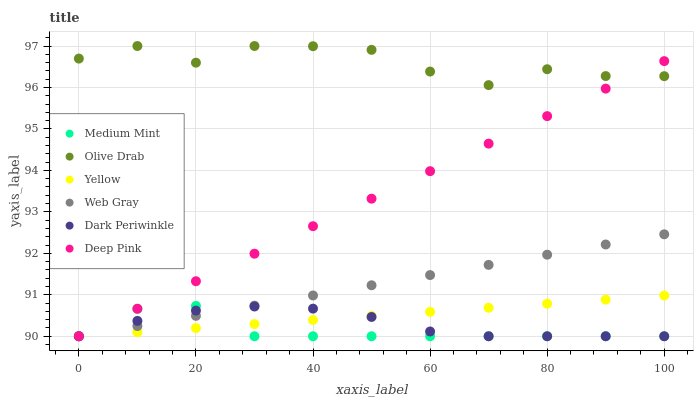Does Medium Mint have the minimum area under the curve?
Answer yes or no. Yes. Does Olive Drab have the maximum area under the curve?
Answer yes or no. Yes. Does Deep Pink have the minimum area under the curve?
Answer yes or no. No. Does Deep Pink have the maximum area under the curve?
Answer yes or no. No. Is Web Gray the smoothest?
Answer yes or no. Yes. Is Olive Drab the roughest?
Answer yes or no. Yes. Is Deep Pink the smoothest?
Answer yes or no. No. Is Deep Pink the roughest?
Answer yes or no. No. Does Medium Mint have the lowest value?
Answer yes or no. Yes. Does Olive Drab have the lowest value?
Answer yes or no. No. Does Olive Drab have the highest value?
Answer yes or no. Yes. Does Deep Pink have the highest value?
Answer yes or no. No. Is Web Gray less than Olive Drab?
Answer yes or no. Yes. Is Olive Drab greater than Dark Periwinkle?
Answer yes or no. Yes. Does Web Gray intersect Medium Mint?
Answer yes or no. Yes. Is Web Gray less than Medium Mint?
Answer yes or no. No. Is Web Gray greater than Medium Mint?
Answer yes or no. No. Does Web Gray intersect Olive Drab?
Answer yes or no. No. 